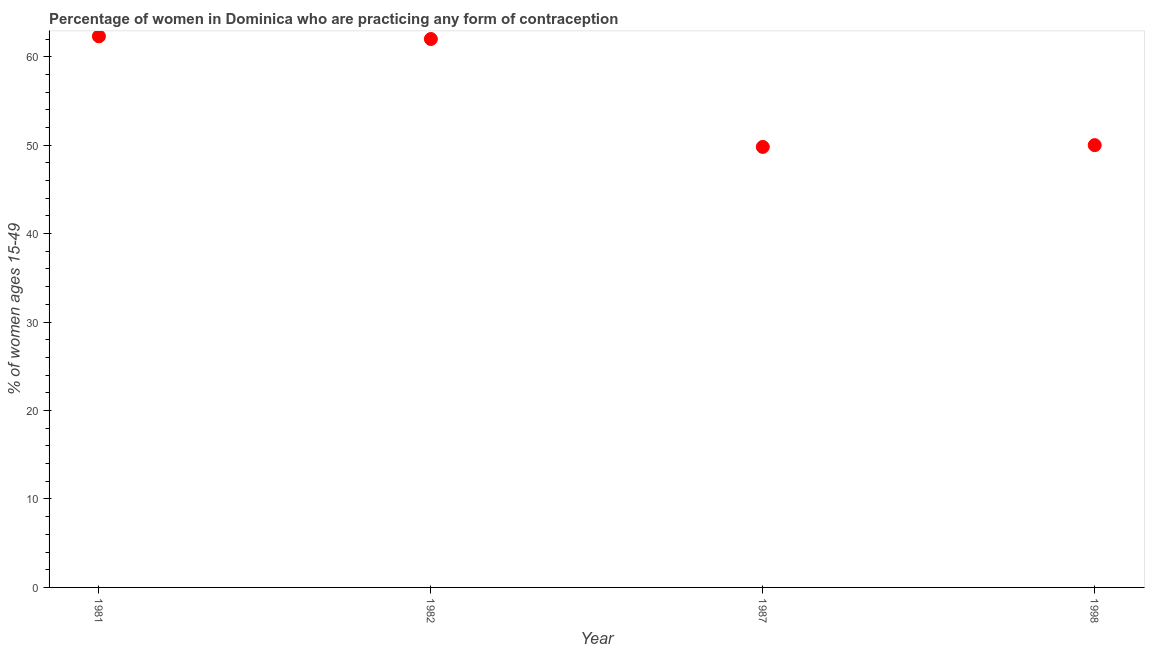What is the contraceptive prevalence in 1987?
Offer a very short reply. 49.8. Across all years, what is the maximum contraceptive prevalence?
Your response must be concise. 62.3. Across all years, what is the minimum contraceptive prevalence?
Your answer should be very brief. 49.8. In which year was the contraceptive prevalence maximum?
Give a very brief answer. 1981. In which year was the contraceptive prevalence minimum?
Offer a very short reply. 1987. What is the sum of the contraceptive prevalence?
Make the answer very short. 224.1. What is the difference between the contraceptive prevalence in 1987 and 1998?
Make the answer very short. -0.2. What is the average contraceptive prevalence per year?
Make the answer very short. 56.02. Do a majority of the years between 1982 and 1981 (inclusive) have contraceptive prevalence greater than 58 %?
Keep it short and to the point. No. What is the ratio of the contraceptive prevalence in 1981 to that in 1998?
Your response must be concise. 1.25. Is the contraceptive prevalence in 1987 less than that in 1998?
Ensure brevity in your answer.  Yes. What is the difference between the highest and the second highest contraceptive prevalence?
Your answer should be very brief. 0.3. In how many years, is the contraceptive prevalence greater than the average contraceptive prevalence taken over all years?
Keep it short and to the point. 2. Does the graph contain grids?
Provide a succinct answer. No. What is the title of the graph?
Your response must be concise. Percentage of women in Dominica who are practicing any form of contraception. What is the label or title of the Y-axis?
Your answer should be very brief. % of women ages 15-49. What is the % of women ages 15-49 in 1981?
Ensure brevity in your answer.  62.3. What is the % of women ages 15-49 in 1982?
Your response must be concise. 62. What is the % of women ages 15-49 in 1987?
Offer a terse response. 49.8. What is the % of women ages 15-49 in 1998?
Offer a terse response. 50. What is the difference between the % of women ages 15-49 in 1981 and 1982?
Offer a terse response. 0.3. What is the difference between the % of women ages 15-49 in 1981 and 1987?
Offer a terse response. 12.5. What is the difference between the % of women ages 15-49 in 1981 and 1998?
Provide a succinct answer. 12.3. What is the difference between the % of women ages 15-49 in 1982 and 1987?
Keep it short and to the point. 12.2. What is the ratio of the % of women ages 15-49 in 1981 to that in 1982?
Your response must be concise. 1. What is the ratio of the % of women ages 15-49 in 1981 to that in 1987?
Your answer should be compact. 1.25. What is the ratio of the % of women ages 15-49 in 1981 to that in 1998?
Ensure brevity in your answer.  1.25. What is the ratio of the % of women ages 15-49 in 1982 to that in 1987?
Give a very brief answer. 1.25. What is the ratio of the % of women ages 15-49 in 1982 to that in 1998?
Provide a succinct answer. 1.24. What is the ratio of the % of women ages 15-49 in 1987 to that in 1998?
Keep it short and to the point. 1. 